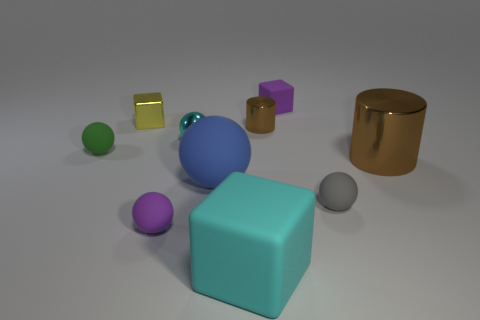Subtract all green spheres. How many spheres are left? 4 Subtract 3 spheres. How many spheres are left? 2 Subtract all cyan spheres. How many spheres are left? 4 Subtract all blue spheres. Subtract all green cylinders. How many spheres are left? 4 Subtract all metal cubes. Subtract all brown things. How many objects are left? 7 Add 9 large balls. How many large balls are left? 10 Add 10 tiny cyan matte cylinders. How many tiny cyan matte cylinders exist? 10 Subtract 1 gray balls. How many objects are left? 9 Subtract all cubes. How many objects are left? 7 